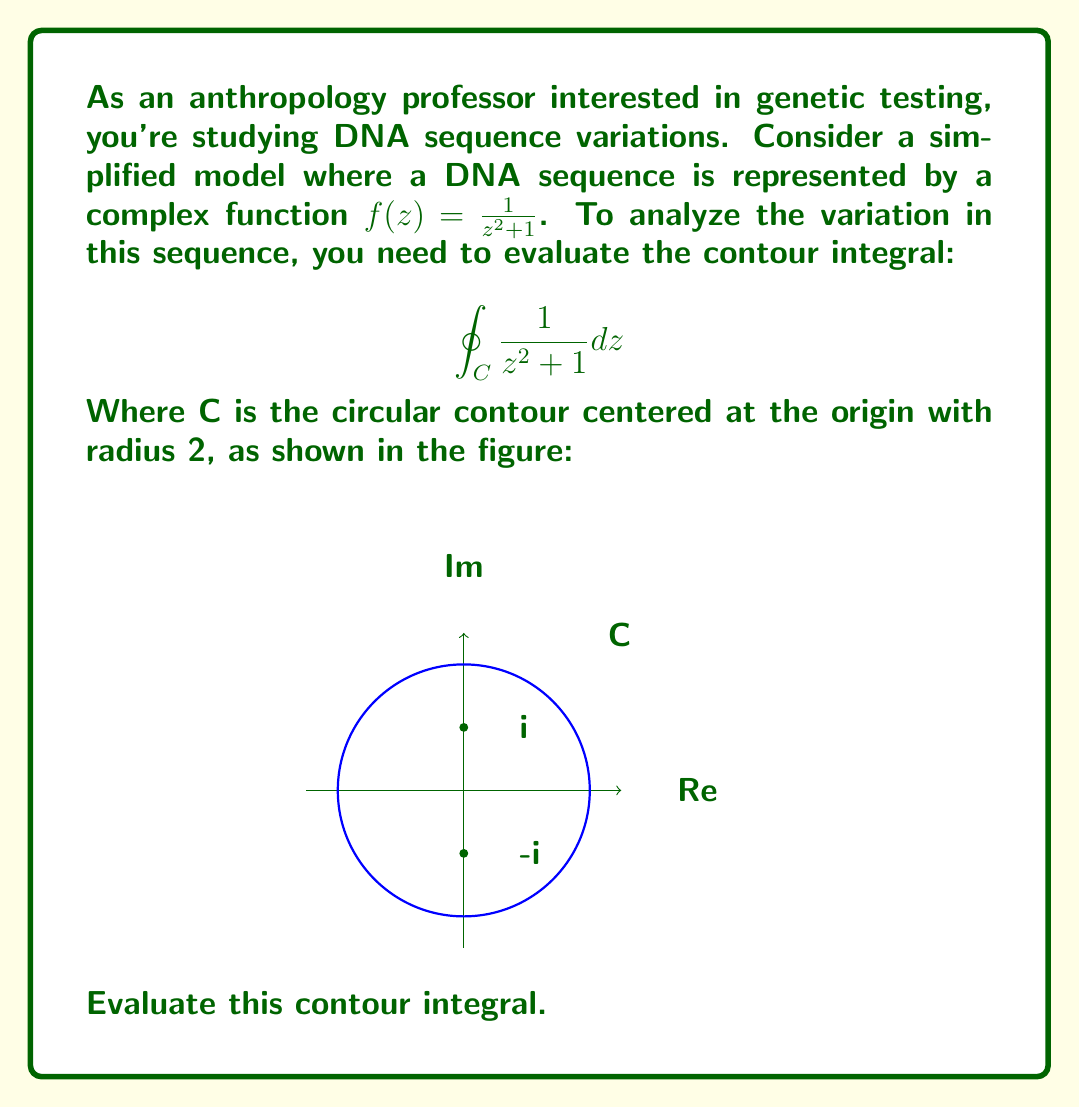Provide a solution to this math problem. Let's approach this step-by-step:

1) The function $f(z) = \frac{1}{z^2 + 1}$ has poles at $z = i$ and $z = -i$. Our contour C encloses both of these poles.

2) We can use the Residue Theorem, which states:

   $$\oint_C f(z) dz = 2\pi i \sum \text{Res}(f, a_k)$$

   where $a_k$ are the poles of $f(z)$ inside C.

3) To find the residues, we need to calculate:

   $$\text{Res}(f, i) = \lim_{z \to i} (z-i) \frac{1}{z^2 + 1}$$
   $$\text{Res}(f, -i) = \lim_{z \to -i} (z+i) \frac{1}{z^2 + 1}$$

4) For $z = i$:
   $$\text{Res}(f, i) = \lim_{z \to i} \frac{z-i}{z^2 + 1} = \lim_{z \to i} \frac{z-i}{(z+i)(z-i)} = \lim_{z \to i} \frac{1}{z+i} = \frac{1}{2i}$$

5) For $z = -i$:
   $$\text{Res}(f, -i) = \lim_{z \to -i} \frac{z+i}{z^2 + 1} = \lim_{z \to -i} \frac{z+i}{(z+i)(z-i)} = \lim_{z \to -i} \frac{1}{z-i} = -\frac{1}{2i}$$

6) Now, we can apply the Residue Theorem:

   $$\oint_C \frac{1}{z^2 + 1} dz = 2\pi i (\frac{1}{2i} - \frac{1}{2i}) = 2\pi i \cdot 0 = 0$$

Therefore, the value of the contour integral is 0.
Answer: $0$ 